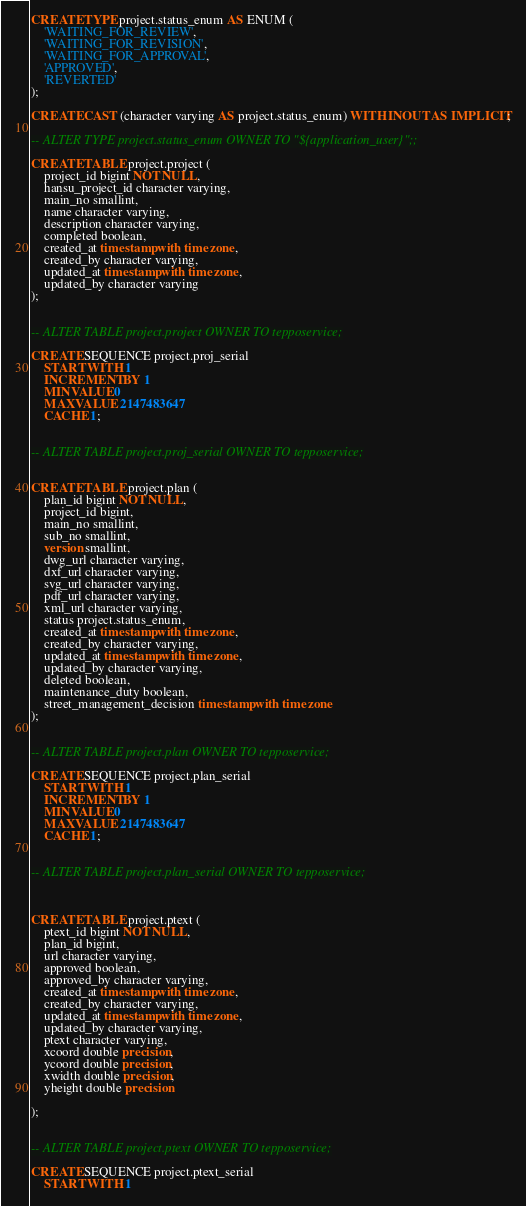<code> <loc_0><loc_0><loc_500><loc_500><_SQL_>CREATE TYPE project.status_enum AS ENUM (
    'WAITING_FOR_REVIEW',
    'WAITING_FOR_REVISION',
    'WAITING_FOR_APPROVAL',
    'APPROVED',
    'REVERTED'
);

CREATE CAST (character varying AS project.status_enum) WITH INOUT AS IMPLICIT;

-- ALTER TYPE project.status_enum OWNER TO "${application_user}";;

CREATE TABLE project.project (
    project_id bigint NOT NULL,
    hansu_project_id character varying,
    main_no smallint,
    name character varying,
    description character varying,
    completed boolean,
    created_at timestamp with time zone,
    created_by character varying,
    updated_at timestamp with time zone,
    updated_by character varying
);


-- ALTER TABLE project.project OWNER TO tepposervice;

CREATE SEQUENCE project.proj_serial
    START WITH 1
    INCREMENT BY 1
    MINVALUE 0
    MAXVALUE 2147483647
    CACHE 1;


-- ALTER TABLE project.proj_serial OWNER TO tepposervice;


CREATE TABLE project.plan (
    plan_id bigint NOT NULL,
    project_id bigint,
    main_no smallint,
    sub_no smallint,
    version smallint,
    dwg_url character varying,
    dxf_url character varying,
    svg_url character varying,
    pdf_url character varying,
    xml_url character varying,
    status project.status_enum,
    created_at timestamp with time zone,
    created_by character varying,
    updated_at timestamp with time zone,
    updated_by character varying,
    deleted boolean,
    maintenance_duty boolean,
    street_management_decision timestamp with time zone
);


-- ALTER TABLE project.plan OWNER TO tepposervice;

CREATE SEQUENCE project.plan_serial
    START WITH 1
    INCREMENT BY 1
    MINVALUE 0
    MAXVALUE 2147483647
    CACHE 1;


-- ALTER TABLE project.plan_serial OWNER TO tepposervice;



CREATE TABLE project.ptext (
    ptext_id bigint NOT NULL,
    plan_id bigint,
    url character varying,
    approved boolean,
    approved_by character varying,
    created_at timestamp with time zone,
    created_by character varying,
    updated_at timestamp with time zone,
    updated_by character varying,
    ptext character varying,
    xcoord double precision,
    ycoord double precision,
    xwidth double precision,
    yheight double precision

);


-- ALTER TABLE project.ptext OWNER TO tepposervice;

CREATE SEQUENCE project.ptext_serial
    START WITH 1</code> 